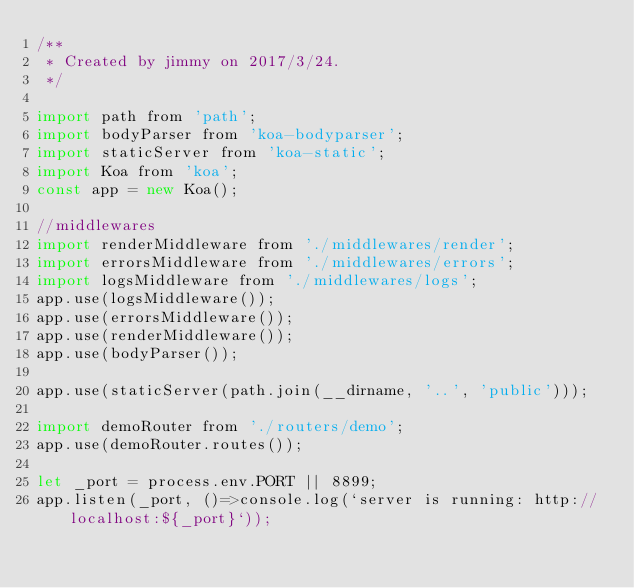<code> <loc_0><loc_0><loc_500><loc_500><_JavaScript_>/**
 * Created by jimmy on 2017/3/24.
 */

import path from 'path';
import bodyParser from 'koa-bodyparser';
import staticServer from 'koa-static';
import Koa from 'koa';
const app = new Koa();

//middlewares
import renderMiddleware from './middlewares/render';
import errorsMiddleware from './middlewares/errors';
import logsMiddleware from './middlewares/logs';
app.use(logsMiddleware());
app.use(errorsMiddleware());
app.use(renderMiddleware());
app.use(bodyParser());

app.use(staticServer(path.join(__dirname, '..', 'public')));

import demoRouter from './routers/demo';
app.use(demoRouter.routes());

let _port = process.env.PORT || 8899;
app.listen(_port, ()=>console.log(`server is running: http://localhost:${_port}`));</code> 